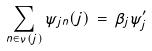Convert formula to latex. <formula><loc_0><loc_0><loc_500><loc_500>\sum _ { n \in \nu ( j ) } \psi _ { j n } ( j ) \, = \, \beta _ { j } \psi ^ { \prime } _ { j }</formula> 